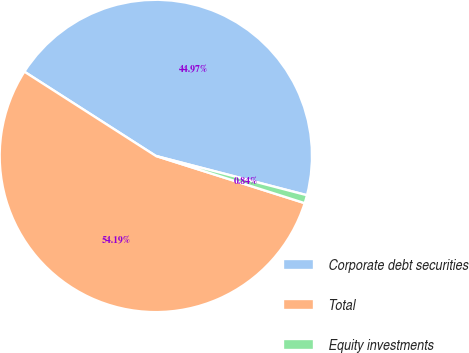Convert chart to OTSL. <chart><loc_0><loc_0><loc_500><loc_500><pie_chart><fcel>Corporate debt securities<fcel>Total<fcel>Equity investments<nl><fcel>44.97%<fcel>54.18%<fcel>0.84%<nl></chart> 